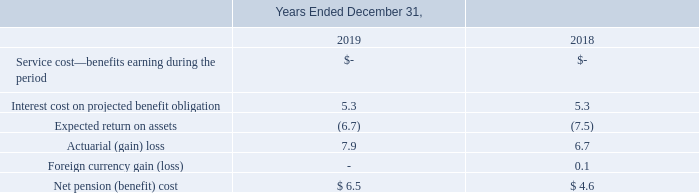Periodic Benefit Costs The aggregate net pension cost recognized in the consolidated statements of operations were costs of $6.5 million and $4.6 million for the years ended December 31, 2019 and 2018, respectively.
The following table presents the components of net periodic benefit cost are as follows (in millions):
Of the amounts presented above, income of $1.4 million has been included in cost of revenue and loss of $7.9 million included in other comprehensive income for the year ended December 31, 2019, and income of $2.1 million has been included in cost of revenue and loss of $6.7 million included in other comprehensive income for the year ended December 31, 2018.
What was the aggregate net pension cost recognized in December 2019? $6.5 million. What was the service cost in 2019?
Answer scale should be: million. -. What was the Expected return on assets in 2019?
Answer scale should be: million. (6.7). What was the average Interest cost on projected benefit obligation?
Answer scale should be: million. (5.3 + 5.3) / 2
Answer: 5.3. What is the increase / (decrease) in the expected return on assets from 2018 to 2019?
Answer scale should be: million. -6.5 - (-7.5)
Answer: 1. What is the average actuarial (gain) loss?
Answer scale should be: million. (7.9 + 6.7) / 2
Answer: 7.3. 